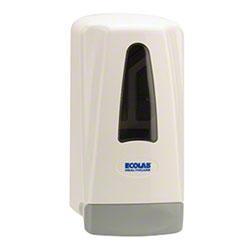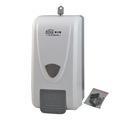The first image is the image on the left, the second image is the image on the right. Considering the images on both sides, is "One or more of the dispensers has a chrome finish." valid? Answer yes or no. No. 